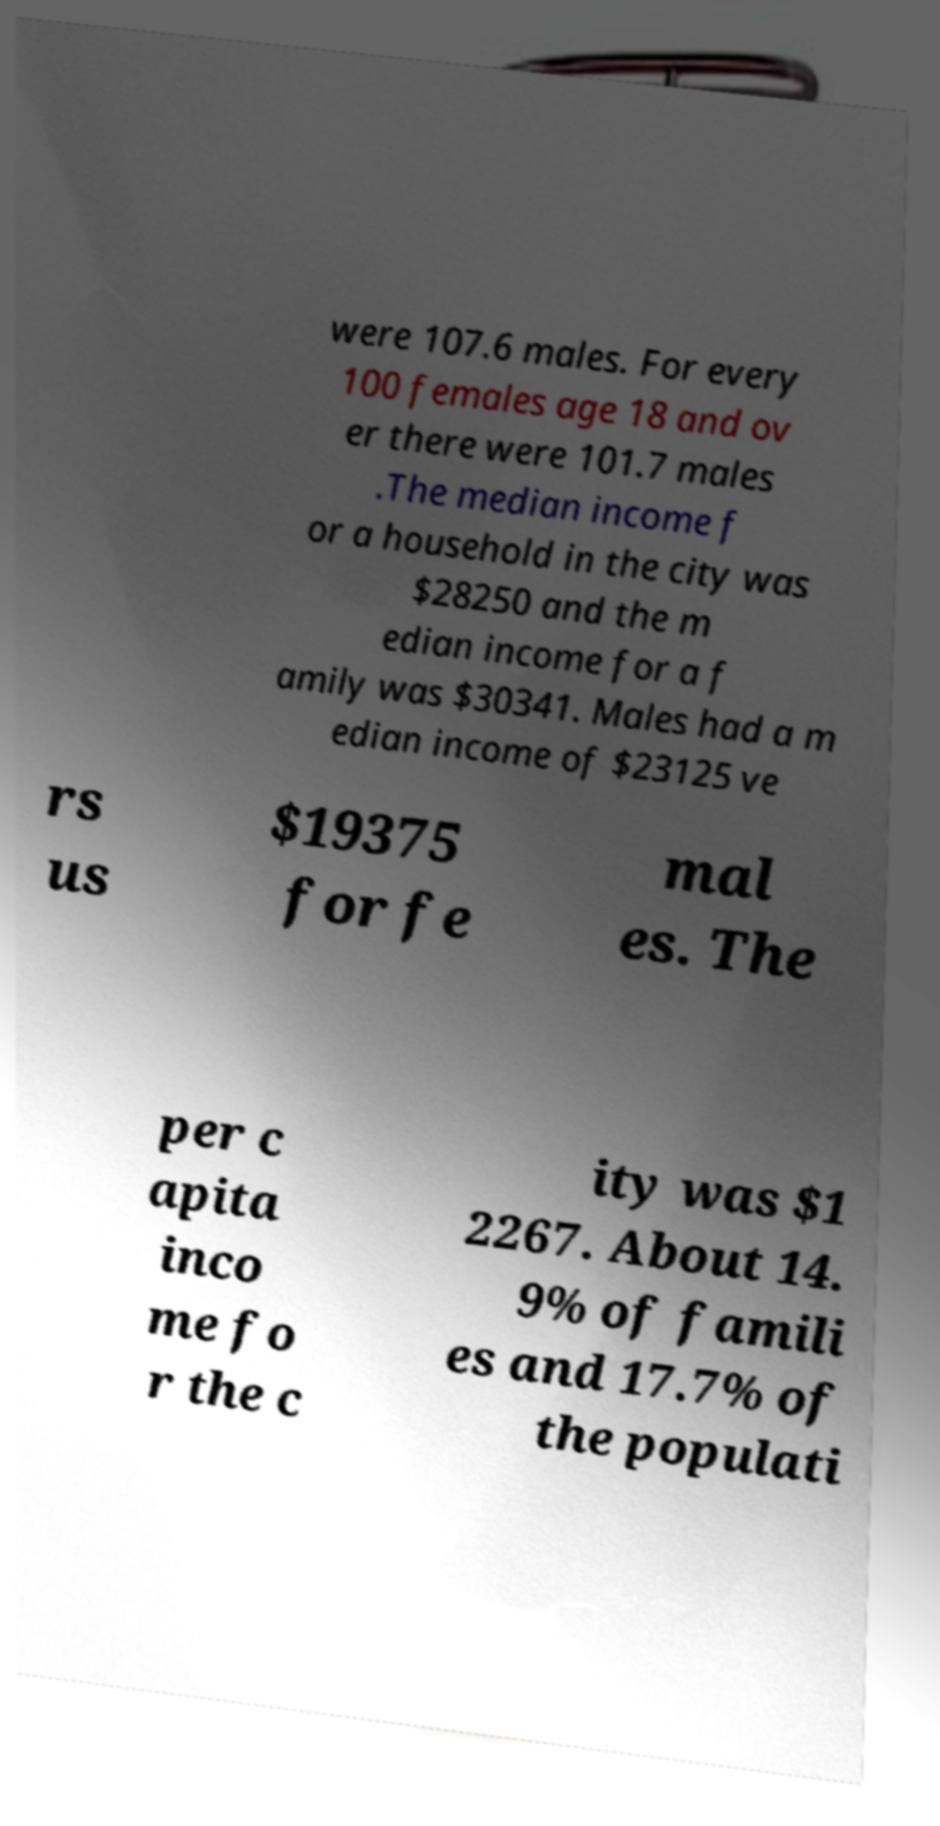There's text embedded in this image that I need extracted. Can you transcribe it verbatim? were 107.6 males. For every 100 females age 18 and ov er there were 101.7 males .The median income f or a household in the city was $28250 and the m edian income for a f amily was $30341. Males had a m edian income of $23125 ve rs us $19375 for fe mal es. The per c apita inco me fo r the c ity was $1 2267. About 14. 9% of famili es and 17.7% of the populati 